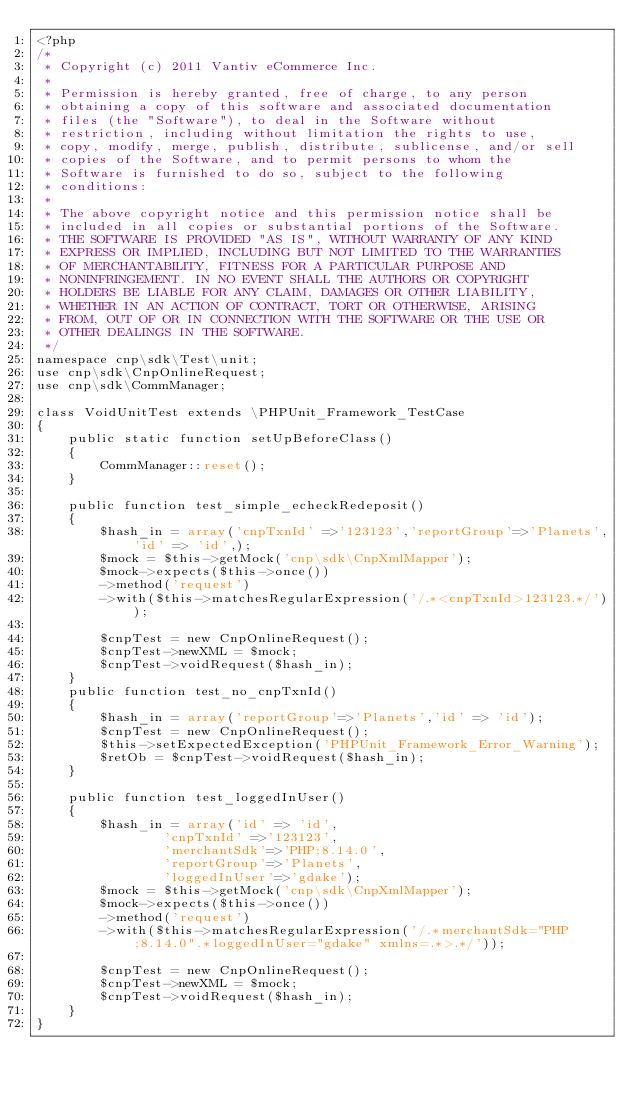<code> <loc_0><loc_0><loc_500><loc_500><_PHP_><?php
/*
 * Copyright (c) 2011 Vantiv eCommerce Inc.
 *
 * Permission is hereby granted, free of charge, to any person
 * obtaining a copy of this software and associated documentation
 * files (the "Software"), to deal in the Software without
 * restriction, including without limitation the rights to use,
 * copy, modify, merge, publish, distribute, sublicense, and/or sell
 * copies of the Software, and to permit persons to whom the
 * Software is furnished to do so, subject to the following
 * conditions:
 *
 * The above copyright notice and this permission notice shall be
 * included in all copies or substantial portions of the Software.
 * THE SOFTWARE IS PROVIDED "AS IS", WITHOUT WARRANTY OF ANY KIND
 * EXPRESS OR IMPLIED, INCLUDING BUT NOT LIMITED TO THE WARRANTIES
 * OF MERCHANTABILITY, FITNESS FOR A PARTICULAR PURPOSE AND
 * NONINFRINGEMENT. IN NO EVENT SHALL THE AUTHORS OR COPYRIGHT
 * HOLDERS BE LIABLE FOR ANY CLAIM, DAMAGES OR OTHER LIABILITY,
 * WHETHER IN AN ACTION OF CONTRACT, TORT OR OTHERWISE, ARISING
 * FROM, OUT OF OR IN CONNECTION WITH THE SOFTWARE OR THE USE OR
 * OTHER DEALINGS IN THE SOFTWARE.
 */
namespace cnp\sdk\Test\unit;
use cnp\sdk\CnpOnlineRequest;
use cnp\sdk\CommManager;

class VoidUnitTest extends \PHPUnit_Framework_TestCase
{
    public static function setUpBeforeClass()
    {
        CommManager::reset();
    }

    public function test_simple_echeckRedeposit()
    {
        $hash_in = array('cnpTxnId' =>'123123','reportGroup'=>'Planets','id' => 'id',);
        $mock = $this->getMock('cnp\sdk\CnpXmlMapper');
        $mock->expects($this->once())
        ->method('request')
        ->with($this->matchesRegularExpression('/.*<cnpTxnId>123123.*/'));

        $cnpTest = new CnpOnlineRequest();
        $cnpTest->newXML = $mock;
        $cnpTest->voidRequest($hash_in);
    }
    public function test_no_cnpTxnId()
    {
        $hash_in = array('reportGroup'=>'Planets','id' => 'id');
        $cnpTest = new CnpOnlineRequest();
        $this->setExpectedException('PHPUnit_Framework_Error_Warning');
        $retOb = $cnpTest->voidRequest($hash_in);
    }

    public function test_loggedInUser()
    {
        $hash_in = array('id' => 'id',
                'cnpTxnId' =>'123123',
                'merchantSdk'=>'PHP;8.14.0',
                'reportGroup'=>'Planets',
                'loggedInUser'=>'gdake');
        $mock = $this->getMock('cnp\sdk\CnpXmlMapper');
        $mock->expects($this->once())
        ->method('request')
        ->with($this->matchesRegularExpression('/.*merchantSdk="PHP;8.14.0".*loggedInUser="gdake" xmlns=.*>.*/'));

        $cnpTest = new CnpOnlineRequest();
        $cnpTest->newXML = $mock;
        $cnpTest->voidRequest($hash_in);
    }
}
</code> 